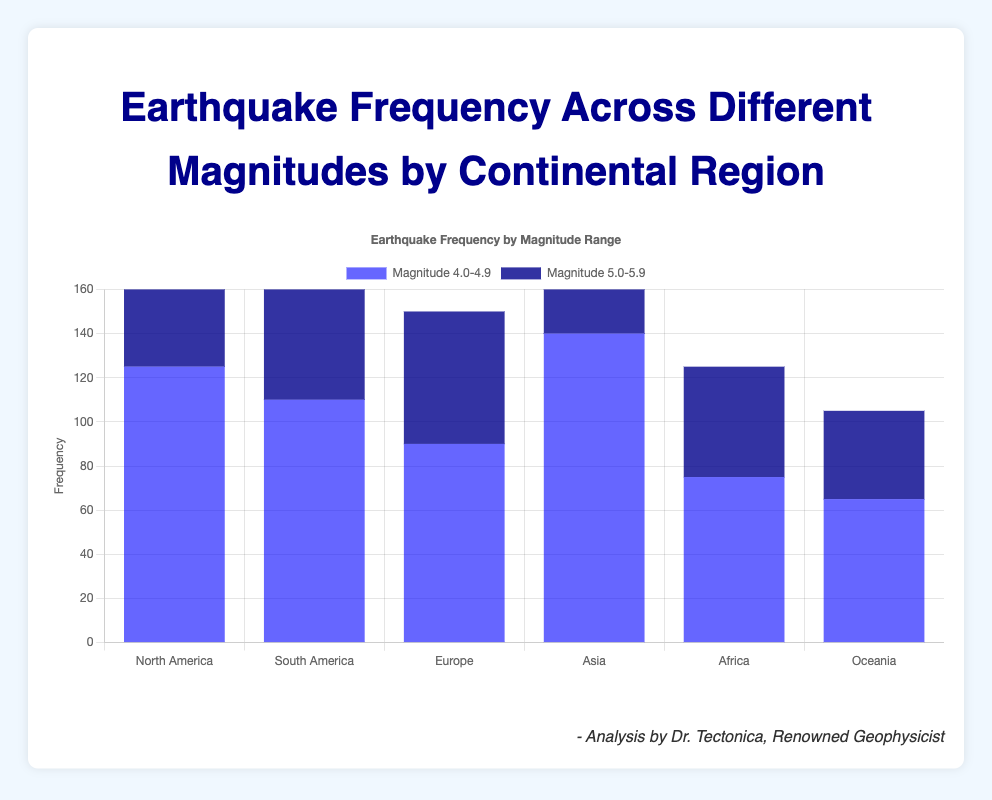What is the total frequency of earthquakes in the 4.0-4.9 magnitude range across all continents? To find the total frequency, sum the frequencies for each continent in the 4.0-4.9 magnitude range: 125 (North America) + 110 (South America) + 90 (Europe) + 140 (Asia) + 75 (Africa) + 65 (Oceania) = 605
Answer: 605 Which continent experienced the highest frequency of 5.0-5.9 magnitude earthquakes? Compare the frequencies of 5.0-5.9 magnitude earthquakes between continents: North America (85), South America (70), Europe (60), Asia (95), Africa (50), Oceania (40). Asia has the highest frequency with 95 earthquakes.
Answer: Asia How does the frequency of 4.0-4.9 magnitude earthquakes compare between North America and Africa? For 4.0-4.9 magnitude earthquakes, North America has 125 and Africa has 75. North America's frequency is higher.
Answer: North America What is the difference in the frequency of 5.0-5.9 magnitude earthquakes between Europe and Oceania? Subtract the frequency of 5.0-5.9 magnitude earthquakes in Oceania from Europe: 60 (Europe) - 40 (Oceania) = 20
Answer: 20 What is the average frequency of 4.0-4.9 magnitude earthquakes across continents? Sum the frequencies of 4.0-4.9 magnitude earthquakes and divide by the number of continents: (125 + 110 + 90 + 140 + 75 + 65) / 6 = 100.83
Answer: 100.83 Which magnitude range has higher total earthquake frequency in South America? Compare the total frequencies for South America: 4.0-4.9 (110) and 5.0-5.9 (70). The frequency of 4.0-4.9 magnitude earthquakes is higher.
Answer: 4.0-4.9 How does the visual height of the bars representing Asia's earthquake frequency for both magnitude ranges compare? The bar for 4.0-4.9 magnitude earthquakes in Asia is taller than the bar for 5.0-5.9 magnitude earthquakes.
Answer: 4.0-4.9 What is the total frequency of earthquakes in the 5.0-5.9 magnitude range across all continents? Sum the frequencies for the 5.0-5.9 magnitude range: 85 (North America) + 70 (South America) + 60 (Europe) + 95 (Asia) + 50 (Africa) + 40 (Oceania) = 400
Answer: 400 What is the ratio of 4.0-4.9 magnitude earthquakes to 5.0-5.9 magnitude earthquakes in Oceania? Divide the frequency of 4.0-4.9 magnitude earthquakes by the frequency of 5.0-5.9 magnitude earthquakes in Oceania: 65 / 40 = 1.625
Answer: 1.625 